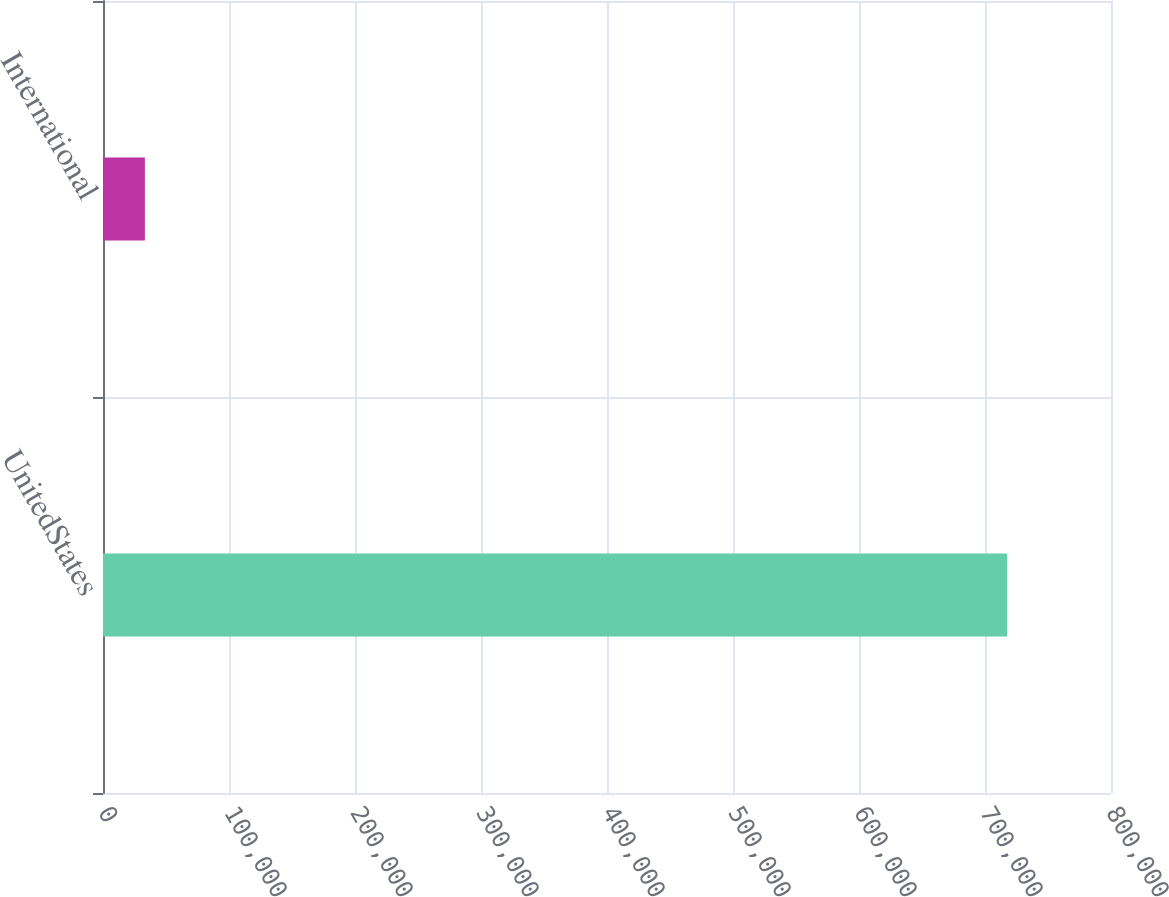Convert chart to OTSL. <chart><loc_0><loc_0><loc_500><loc_500><bar_chart><fcel>UnitedStates<fcel>International<nl><fcel>717614<fcel>33237<nl></chart> 